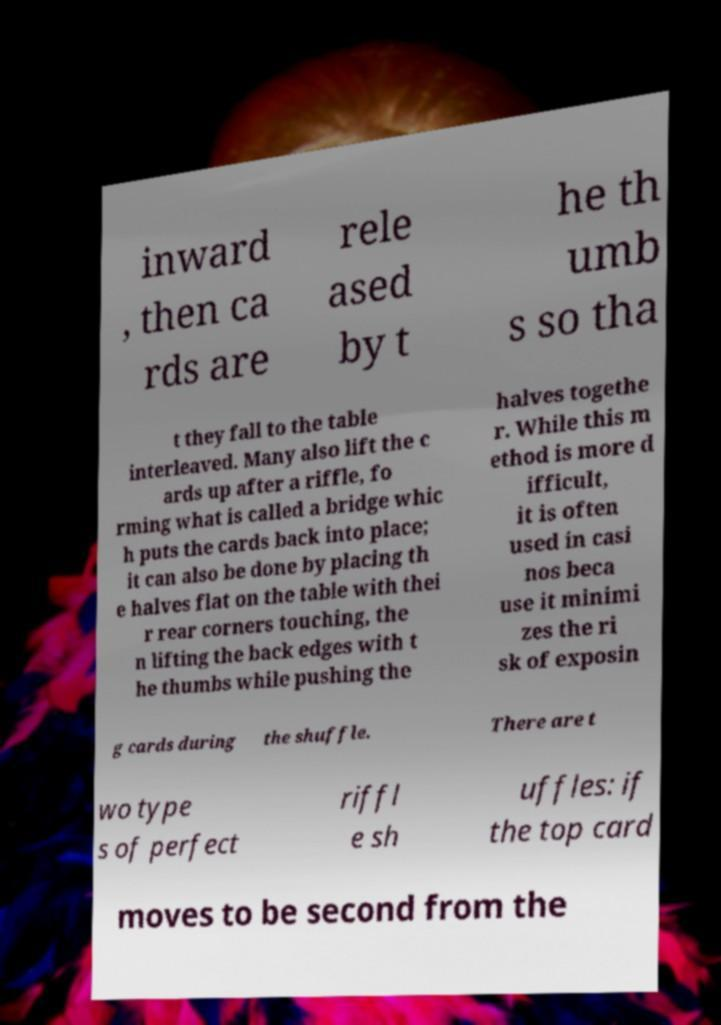What messages or text are displayed in this image? I need them in a readable, typed format. inward , then ca rds are rele ased by t he th umb s so tha t they fall to the table interleaved. Many also lift the c ards up after a riffle, fo rming what is called a bridge whic h puts the cards back into place; it can also be done by placing th e halves flat on the table with thei r rear corners touching, the n lifting the back edges with t he thumbs while pushing the halves togethe r. While this m ethod is more d ifficult, it is often used in casi nos beca use it minimi zes the ri sk of exposin g cards during the shuffle. There are t wo type s of perfect riffl e sh uffles: if the top card moves to be second from the 